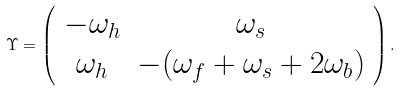<formula> <loc_0><loc_0><loc_500><loc_500>\Upsilon = \left ( \begin{array} { c c } - \omega _ { h } & \omega _ { s } \\ \omega _ { h } & - ( \omega _ { f } + \omega _ { s } + 2 \omega _ { b } ) \end{array} \right ) .</formula> 